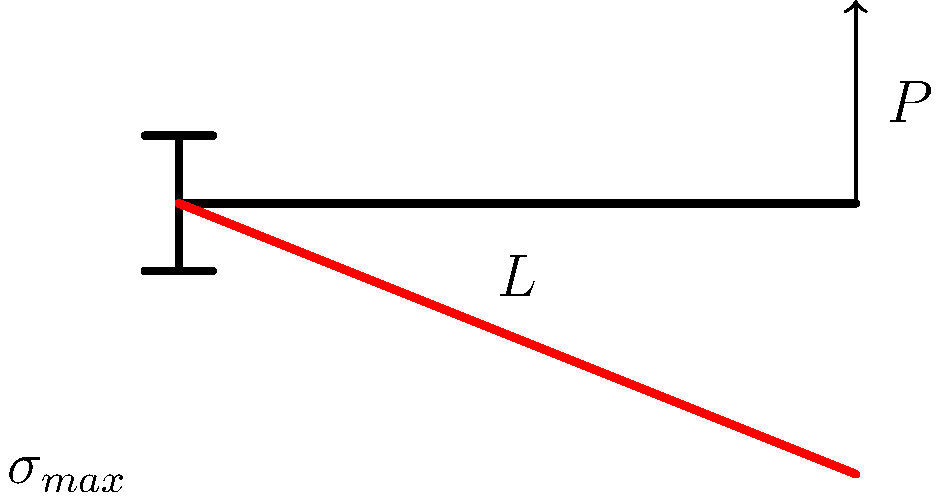In the context of visual storytelling, imagine a cantilever beam as a metaphor for narrative structure. If the beam represents the story's timeline and the point load symbolizes the climax, how would you describe the distribution of narrative tension (stress) along the story arc, and where would the maximum tension occur? To understand this metaphor, let's break down the stress distribution in a cantilever beam and relate it to storytelling:

1. In a cantilever beam with a point load at the free end:
   - The stress distribution is linear, with maximum stress at the fixed end.
   - The stress decreases linearly towards the free end.

2. Translating this to storytelling:
   - The fixed end represents the beginning of the story.
   - The free end with the point load represents the climax.
   - The length of the beam represents the story's timeline.

3. Narrative tension distribution:
   - The maximum tension (stress) occurs at the story's beginning (fixed end).
   - Tension gradually decreases as the story progresses towards the climax.
   - This counterintuitive distribution suggests that the setup and initial conflict create the most "stress" on the narrative structure.

4. Interpretation for filmmaking:
   - The high initial tension implies the importance of a strong opening that hooks the audience.
   - The gradual decrease in tension doesn't mean less excitement, but rather a more focused and directed narrative as it approaches the climax.
   - The point load (climax) at the end creates a sudden impact, resolving the built-up tension.

5. Mathematical representation:
   The stress at any point along the beam (story) can be represented by:
   $$\sigma(x) = \frac{P(L-x)y}{I}$$
   Where $P$ is the load (climax impact), $L$ is the beam length (story duration), $x$ is the distance from the fixed end, $y$ is the distance from the neutral axis, and $I$ is the moment of inertia.

This stress distribution metaphor encourages filmmakers to consider how they build and maintain tension throughout their narrative, emphasizing the importance of a strong beginning and a well-crafted journey towards the climax.
Answer: Maximum narrative tension at the story's beginning, decreasing linearly towards the climax. 